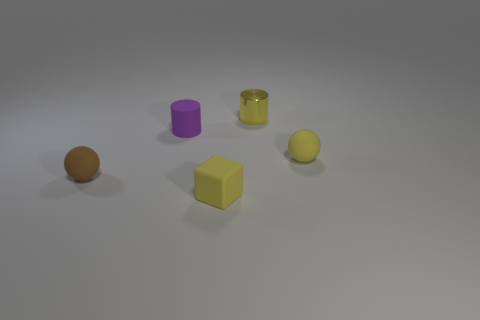Add 3 big purple things. How many objects exist? 8 Subtract all spheres. How many objects are left? 3 Subtract 0 gray cubes. How many objects are left? 5 Subtract all red blocks. Subtract all blue spheres. How many blocks are left? 1 Subtract all balls. Subtract all small brown rubber objects. How many objects are left? 2 Add 2 tiny brown rubber objects. How many tiny brown rubber objects are left? 3 Add 4 green matte things. How many green matte things exist? 4 